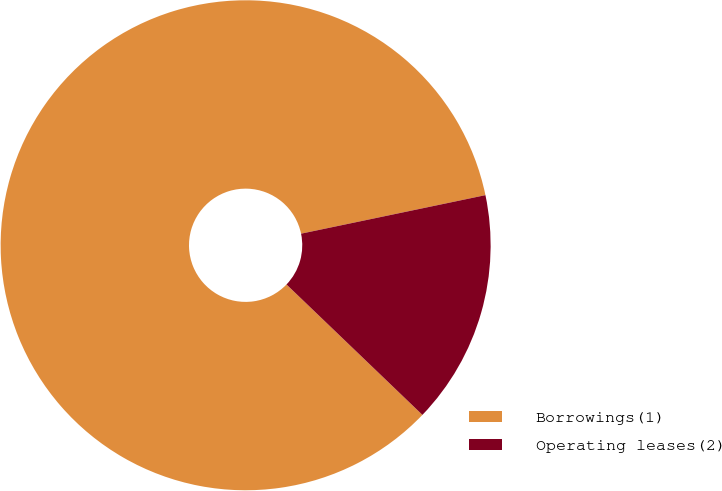Convert chart to OTSL. <chart><loc_0><loc_0><loc_500><loc_500><pie_chart><fcel>Borrowings(1)<fcel>Operating leases(2)<nl><fcel>84.55%<fcel>15.45%<nl></chart> 